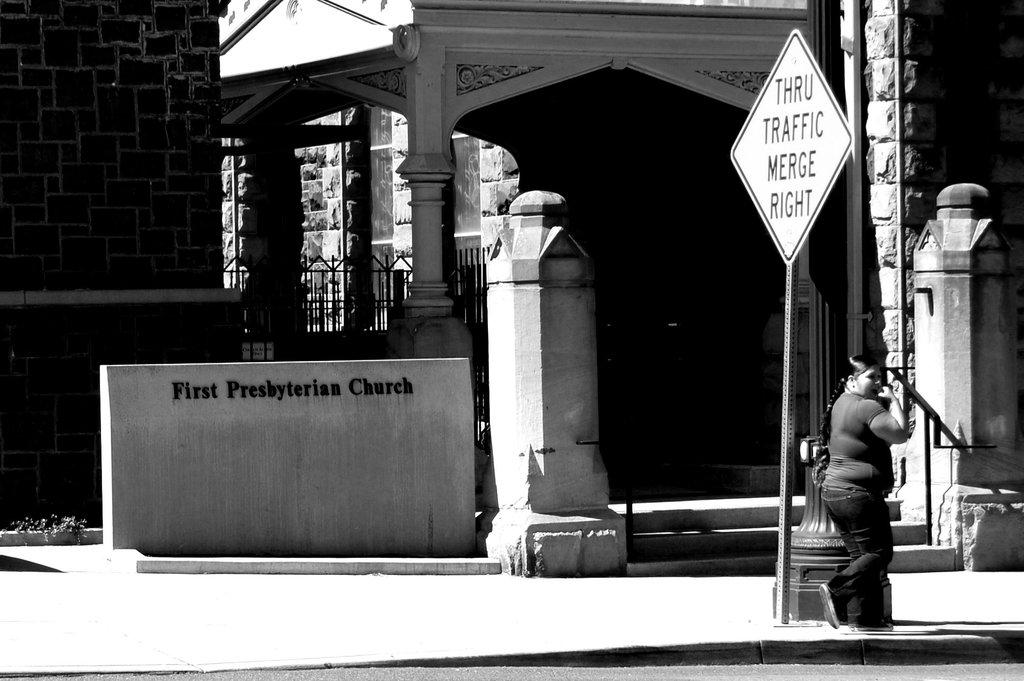What is happening on the left side of the image? There is a woman walking on the left side of the image. What can be seen in the distance in the image? There are buildings and boards in the background of the image. What surface is the woman walking on? There is a footpath at the bottom of the image. Can you see the woman's mother walking with her in the image? There is no mention of the woman's mother in the image, so we cannot determine if she is present or not. 